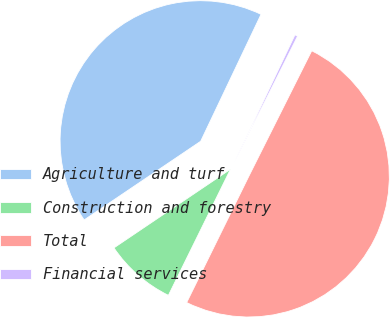<chart> <loc_0><loc_0><loc_500><loc_500><pie_chart><fcel>Agriculture and turf<fcel>Construction and forestry<fcel>Total<fcel>Financial services<nl><fcel>41.52%<fcel>8.27%<fcel>49.89%<fcel>0.33%<nl></chart> 